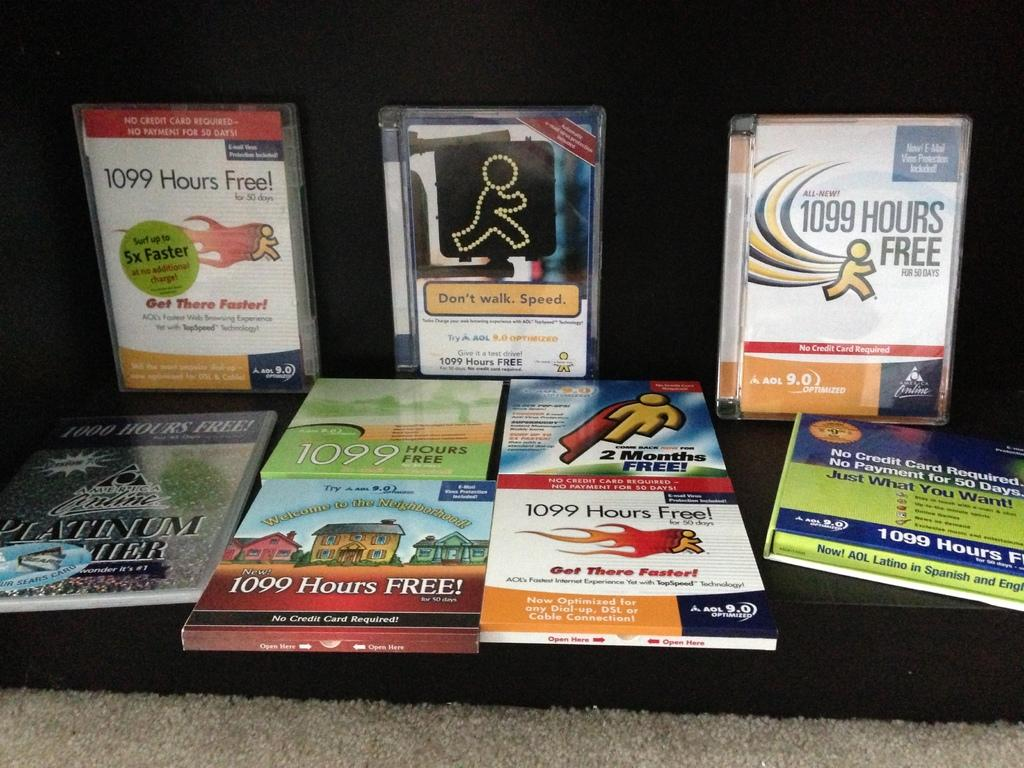Provide a one-sentence caption for the provided image. A display of CD cases and books for AOL features 1099 hours free is on display in front of a black box. 